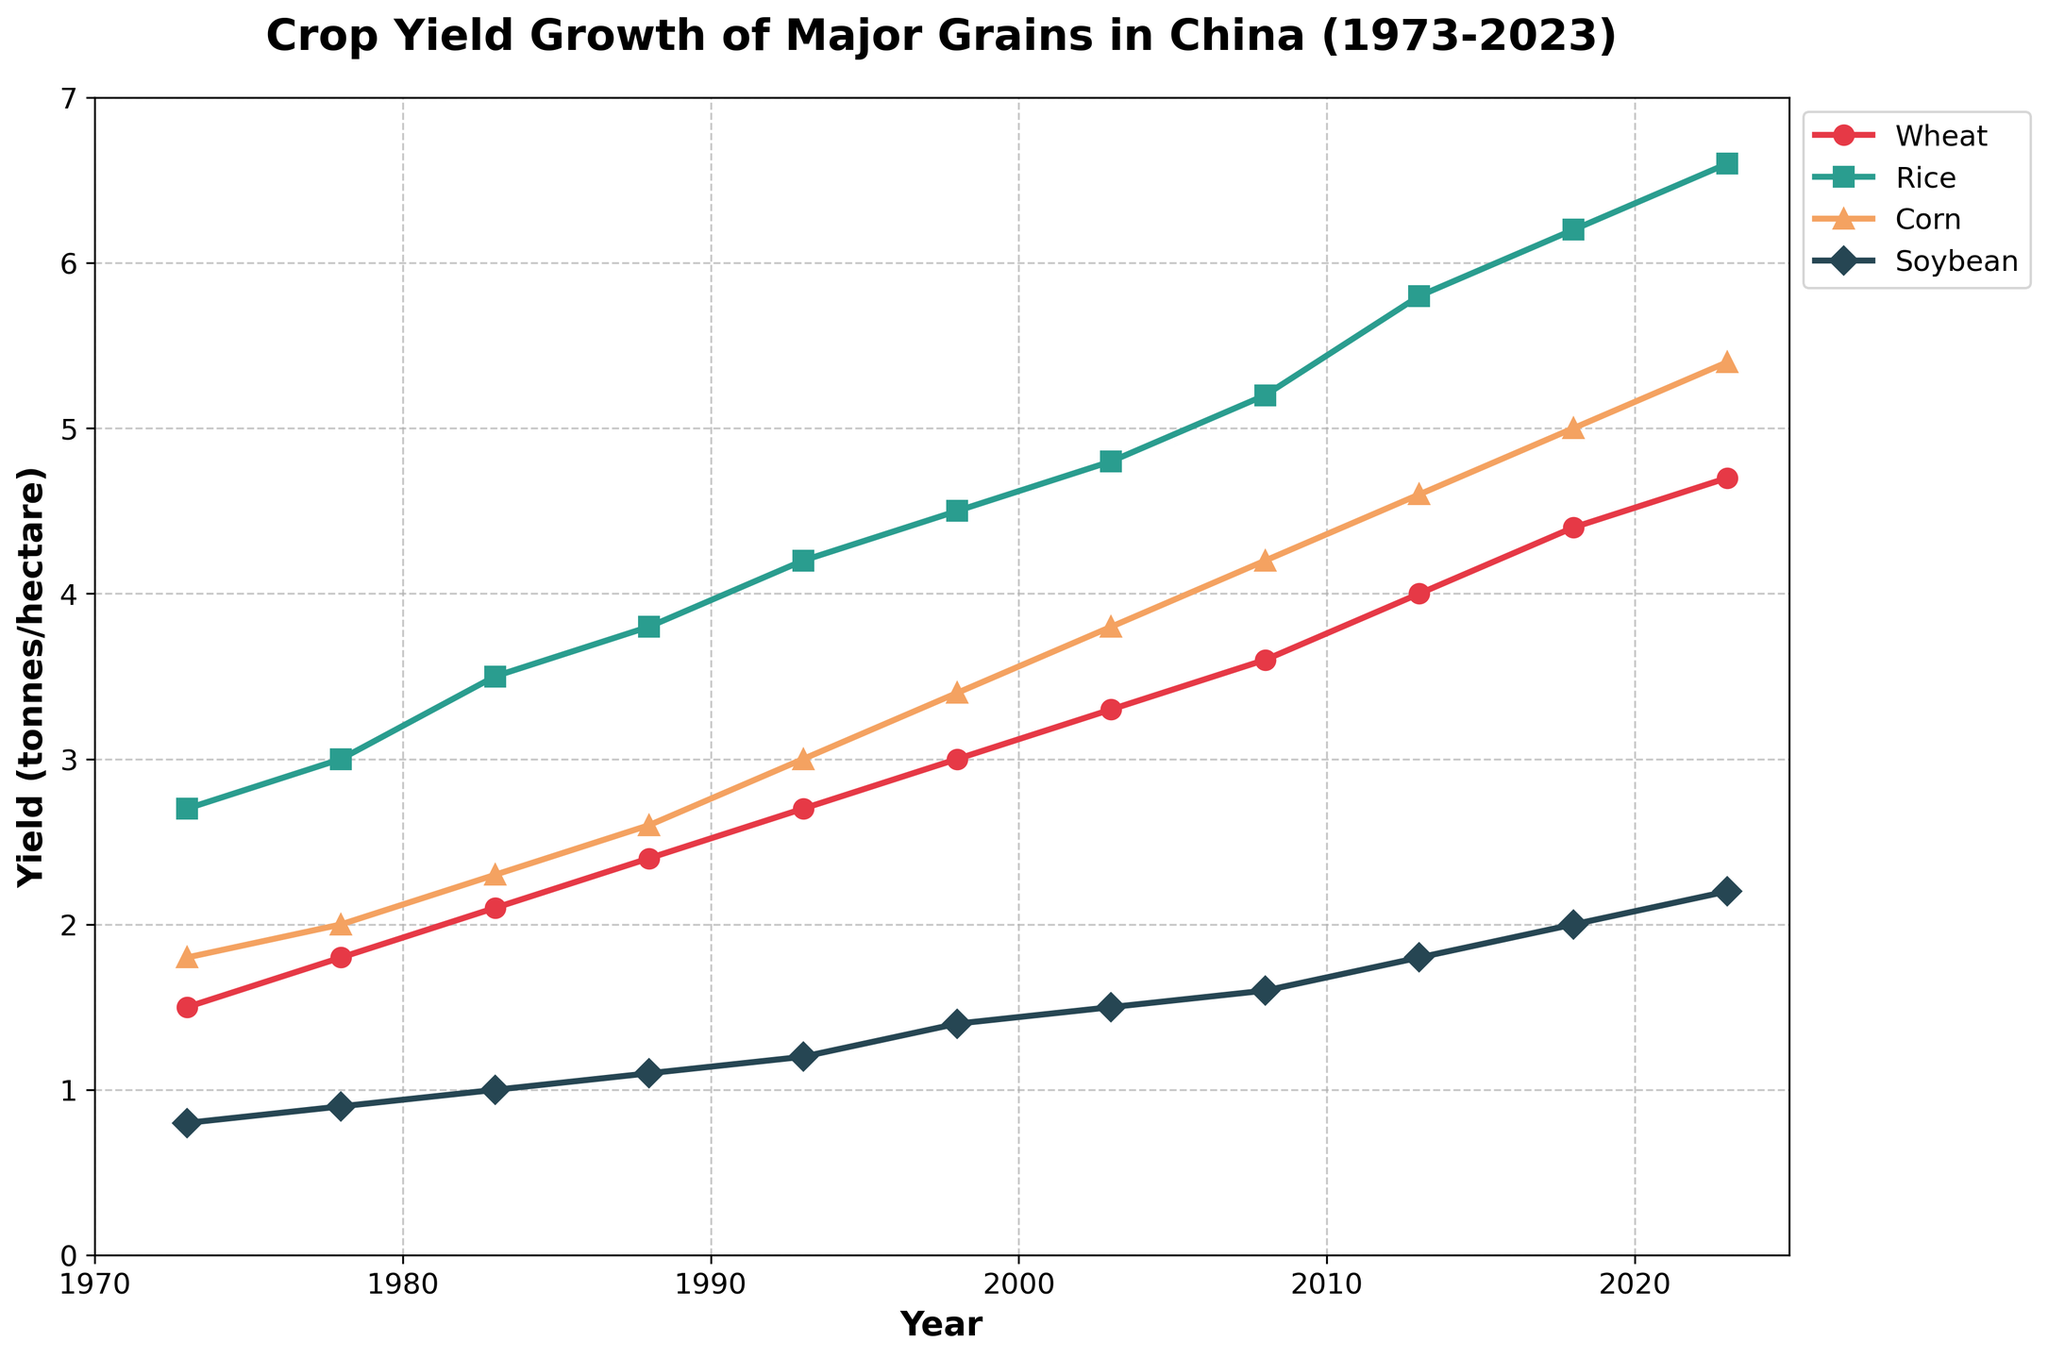What's the title of the plot? The title of the plot is prominently displayed at the top and reads 'Crop Yield Growth of Major Grains in China (1973-2023)'.
Answer: Crop Yield Growth of Major Grains in China (1973-2023) How many major grains are being tracked in the plot? The legend in the plot lists four different grains, which are Wheat, Rice, Corn, and Soybean.
Answer: Four What is the yield of rice in the year 1988? Look at the data point on the line for Rice in the year 1988, which is marked with a specific marker corresponding to Rice. The y-axis value for Rice at 1988 is 3.8 tonnes/hectare.
Answer: 3.8 tonnes/hectare Which grain had the highest yield in 2023? Among the yields of Wheat (4.7), Rice (6.6), Corn (5.4), and Soybean (2.2) in 2023, Rice has the highest yield.
Answer: Rice Between which years did the yield of Wheat surpass 3 tonnes/hectare? Identify the trend line for Wheat and find the year where the y-axis value first exceeds 3.0 tonnes/hectare, which happens between 1993 and 1998.
Answer: 1993 to 1998 What's the average yield of Soybean for the years 1973, 1978, and 1983? Soybean yields for those years are 0.8, 0.9, and 1.0 respectively. The average is calculated as (0.8 + 0.9 + 1.0) / 3 = 0.9 tonnes/hectare.
Answer: 0.9 tonnes/hectare Which crop had the most significant yield increase from 1973 to 2023? Subtract the 1973 yield from the 2023 yield for each crop and compare the differences. Wheat: 4.7-1.5=3.2, Rice: 6.6-2.7=3.9, Corn: 5.4-1.8=3.6, Soybean: 2.2-0.8=1.4. Rice increased the most by 3.9 tonnes/hectare.
Answer: Rice What is the overall trend of crop yields from 1973 to 2023? All the crop lines (Wheat, Rice, Corn, Soybean) show an upward trend from 1973 to 2023, indicating an overall increase in yields.
Answer: Upward trend Is there any year where all crops had their yields increased compared to the previous recorded year? For each year listed, compare the yields of Wheat, Rice, Corn, and Soybean to their values in the previous recorded year. For example, yields in 1993 compared to 1988: Wheat (2.7 > 2.4), Rice (4.2 > 3.8), Corn (3.0 > 2.6), Soybean (1.2 > 1.1) all increased.
Answer: 1993 